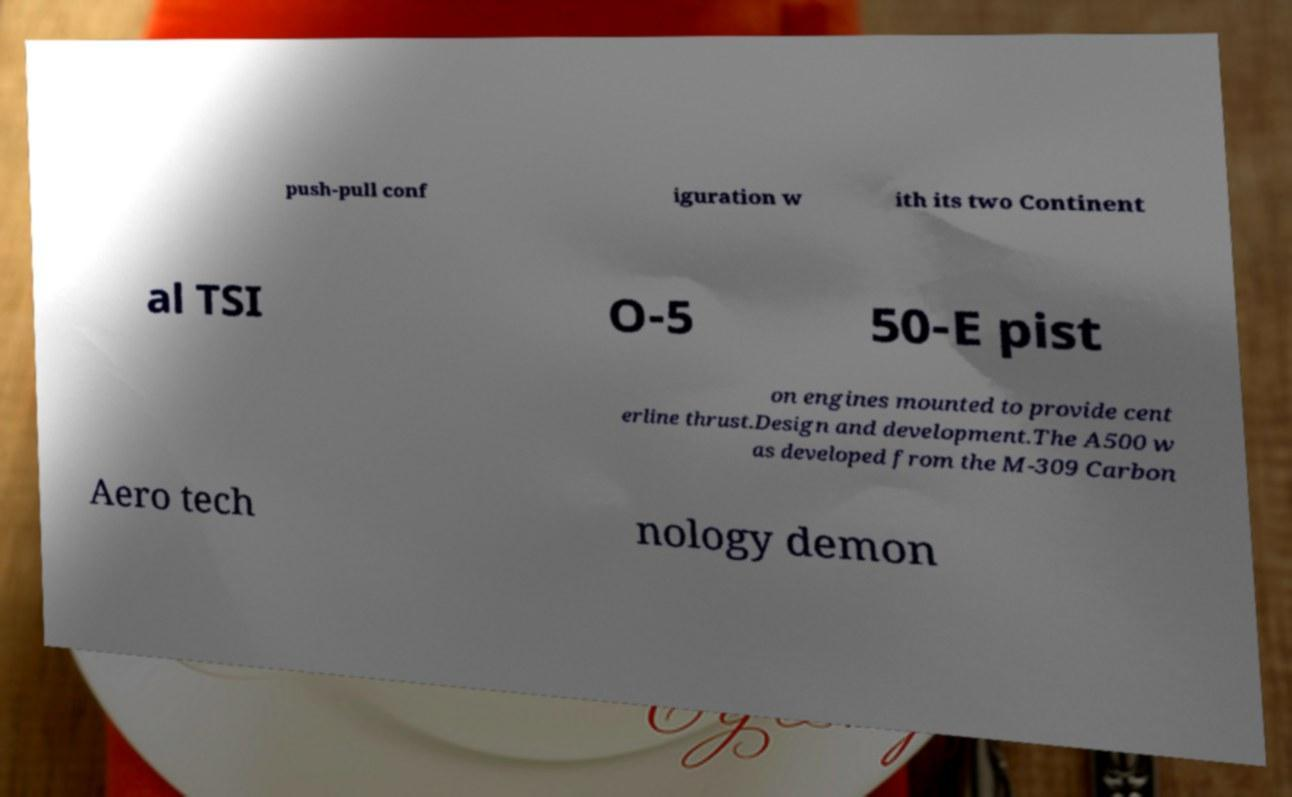Can you accurately transcribe the text from the provided image for me? push-pull conf iguration w ith its two Continent al TSI O-5 50-E pist on engines mounted to provide cent erline thrust.Design and development.The A500 w as developed from the M-309 Carbon Aero tech nology demon 